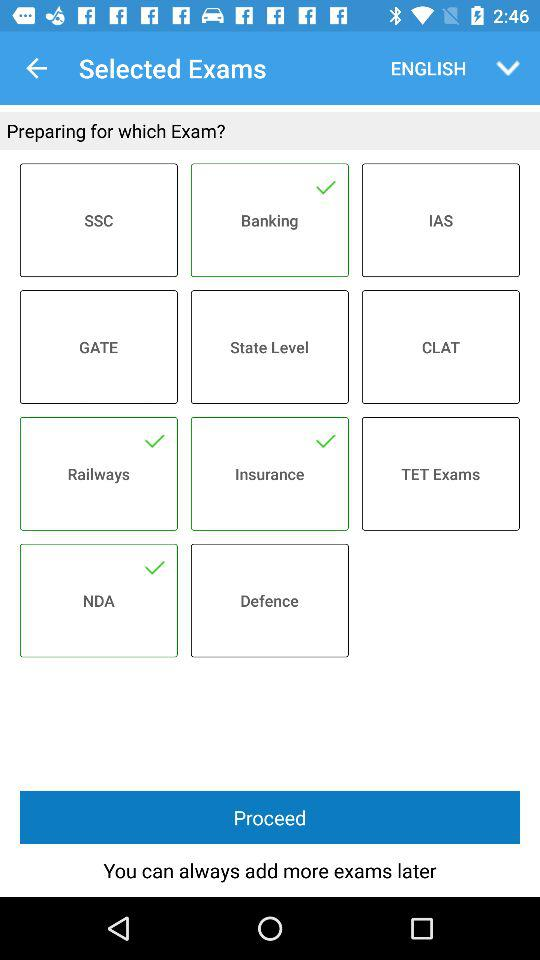Which other exam subjects are available other than English?
When the provided information is insufficient, respond with <no answer>. <no answer> 